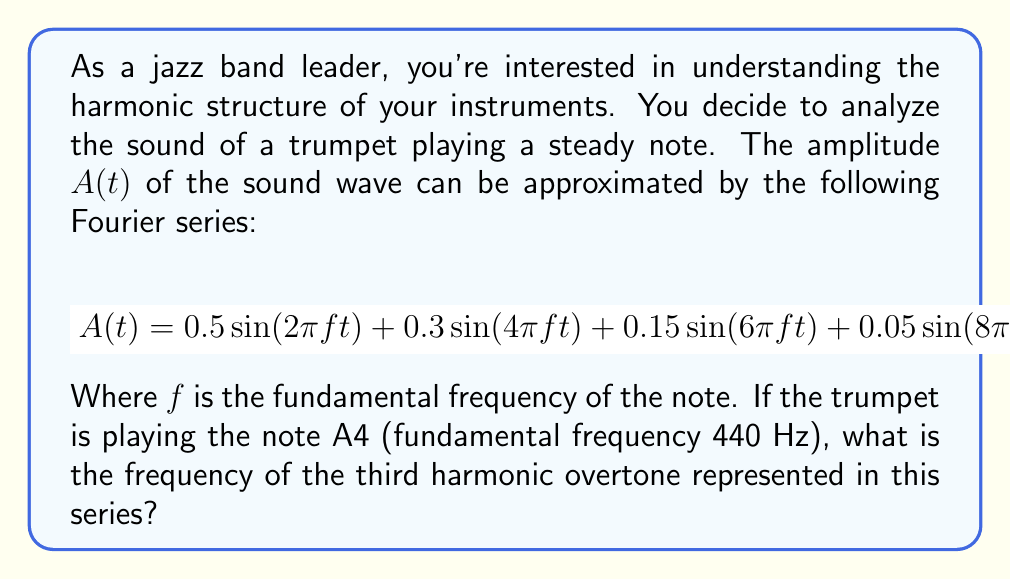Help me with this question. To solve this problem, we need to understand the concept of harmonic overtones and how they relate to the Fourier series representation of a sound wave.

1) In a Fourier series, each term represents a sinusoidal component of the complex waveform. The frequency of each component is an integer multiple of the fundamental frequency.

2) The fundamental frequency (first harmonic) is represented by the term with the lowest frequency, in this case $\sin(2\pi ft)$.

3) The subsequent terms represent the overtones:
   - $\sin(4\pi ft)$ represents the 2nd harmonic (1st overtone)
   - $\sin(6\pi ft)$ represents the 3rd harmonic (2nd overtone)
   - $\sin(8\pi ft)$ represents the 4th harmonic (3rd overtone)

4) We're asked about the third harmonic overtone, which is the 4th harmonic overall.

5) The frequency of this component is 4 times the fundamental frequency:

   $f_{4th harmonic} = 4 * f_{fundamental}$

6) We're given that the fundamental frequency (A4) is 440 Hz.

7) Therefore, the frequency of the third harmonic overtone is:

   $f_{3rd overtone} = 4 * 440 Hz = 1760 Hz$

This frequency corresponds to the note A6, two octaves above the fundamental.
Answer: 1760 Hz 